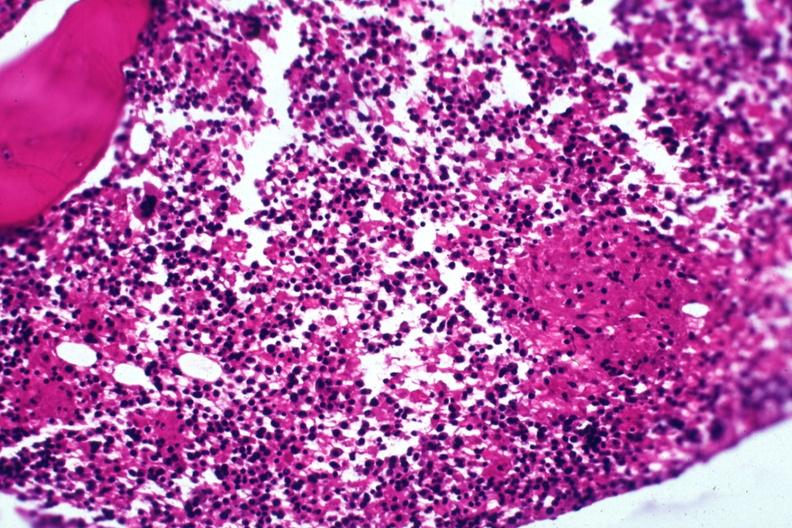what is present?
Answer the question using a single word or phrase. Hematologic 